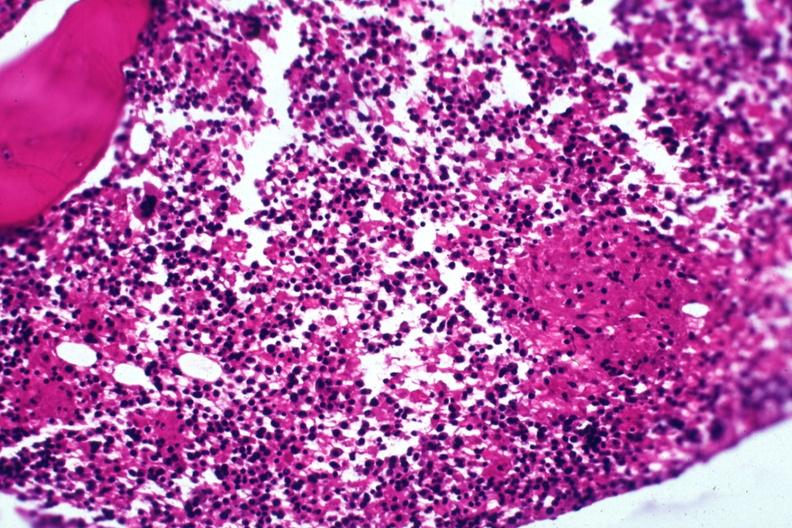what is present?
Answer the question using a single word or phrase. Hematologic 